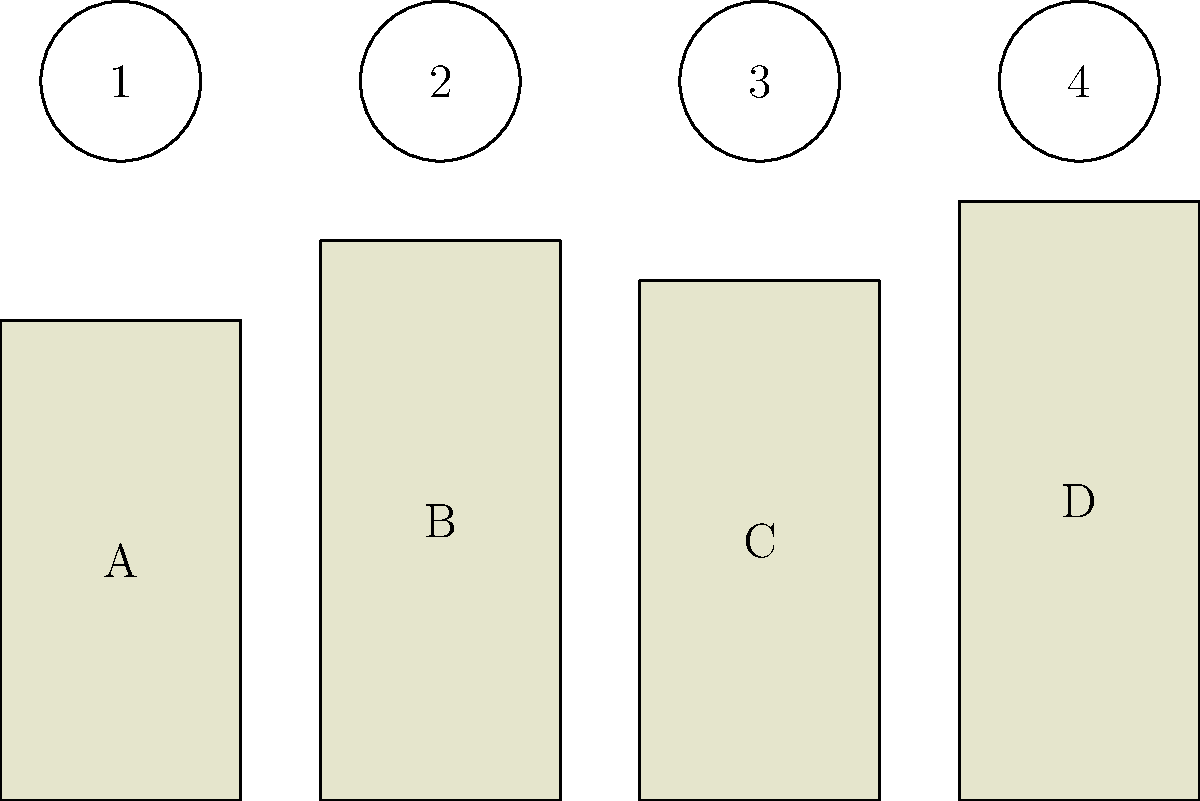Match the authors' portraits (numbered 1-4) to their corresponding book spines (labeled A-D). Which combination correctly pairs all authors with their books? To solve this question, we need to analyze the visual cues provided in the image and use our knowledge of literature to make the correct connections. Let's break it down step-by-step:

1. We see four book spines labeled A, B, C, and D, and four author portraits numbered 1, 2, 3, and 4.

2. The book spines have different heights, which could represent the relative length or prominence of the works:
   A: Shortest
   B: Medium height
   C: Medium-short height
   D: Tallest

3. In a typical book club setting, we would expect to see classic and contemporary works. Let's assume these represent four well-known authors:
   - Ernest Hemingway (known for concise writing)
   - Virginia Woolf (known for stream of consciousness novels)
   - F. Scott Fitzgerald (known for "The Great Gatsby")
   - Leo Tolstoy (known for long, epic novels)

4. Based on this assumption, we can make the following connections:
   A (shortest): Hemingway (1)
   B (medium): Fitzgerald (3)
   C (medium-short): Woolf (2)
   D (tallest): Tolstoy (4)

5. Therefore, the correct pairing would be:
   1-A, 2-C, 3-B, 4-D

This combination logically pairs the authors with their book spines based on the visual representation and our literary knowledge.
Answer: 1-A, 2-C, 3-B, 4-D 